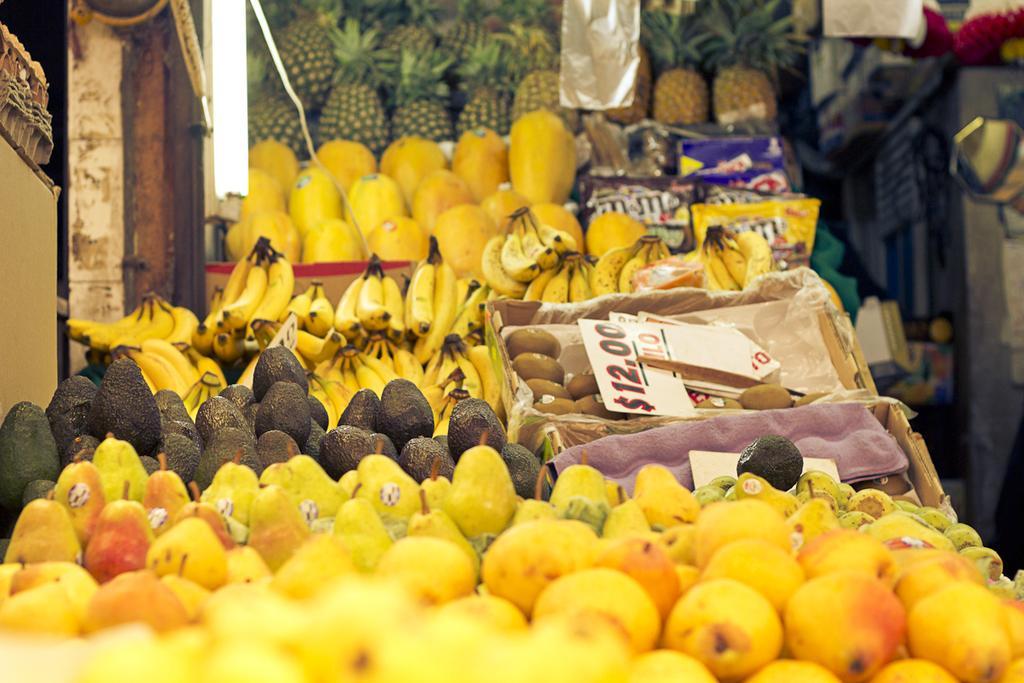Could you give a brief overview of what you see in this image? In this image we can see fruits in baskets. 